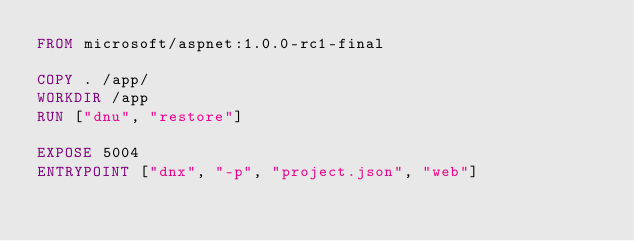Convert code to text. <code><loc_0><loc_0><loc_500><loc_500><_Dockerfile_>FROM microsoft/aspnet:1.0.0-rc1-final

COPY . /app/
WORKDIR /app
RUN ["dnu", "restore"]

EXPOSE 5004
ENTRYPOINT ["dnx", "-p", "project.json", "web"]
</code> 